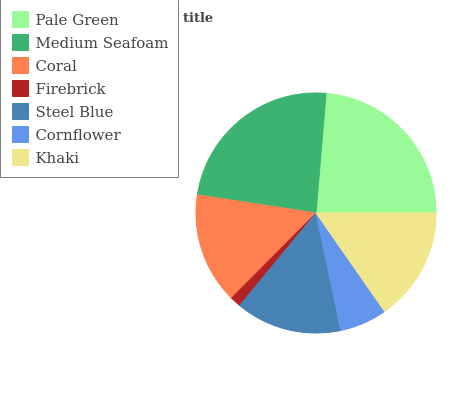Is Firebrick the minimum?
Answer yes or no. Yes. Is Medium Seafoam the maximum?
Answer yes or no. Yes. Is Coral the minimum?
Answer yes or no. No. Is Coral the maximum?
Answer yes or no. No. Is Medium Seafoam greater than Coral?
Answer yes or no. Yes. Is Coral less than Medium Seafoam?
Answer yes or no. Yes. Is Coral greater than Medium Seafoam?
Answer yes or no. No. Is Medium Seafoam less than Coral?
Answer yes or no. No. Is Coral the high median?
Answer yes or no. Yes. Is Coral the low median?
Answer yes or no. Yes. Is Pale Green the high median?
Answer yes or no. No. Is Cornflower the low median?
Answer yes or no. No. 